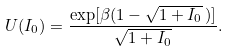Convert formula to latex. <formula><loc_0><loc_0><loc_500><loc_500>U ( I _ { 0 } ) = \frac { \exp [ \beta ( 1 - \sqrt { 1 + I _ { 0 } } \, ) ] } { \sqrt { 1 + I _ { 0 } } } .</formula> 